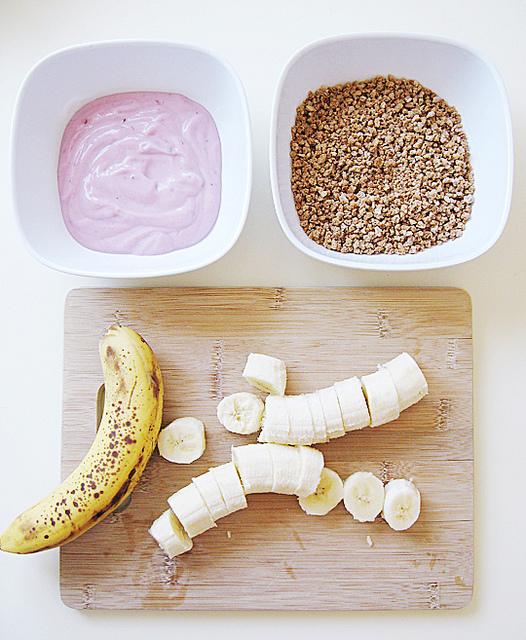How many slices of banana?
Quick response, please. 20. How many bowls have toppings?
Short answer required. 2. Will the bananas be dipped in toppings?
Quick response, please. Yes. 